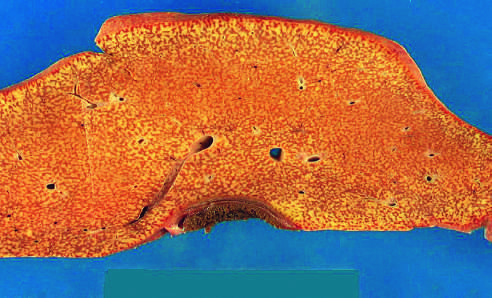how is the liver?
Answer the question using a single word or phrase. Small (700g) 